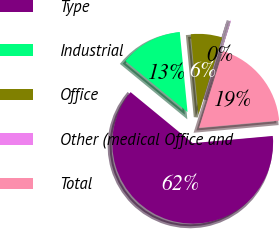Convert chart to OTSL. <chart><loc_0><loc_0><loc_500><loc_500><pie_chart><fcel>Type<fcel>Industrial<fcel>Office<fcel>Other (medical Office and<fcel>Total<nl><fcel>62.38%<fcel>12.52%<fcel>6.29%<fcel>0.06%<fcel>18.75%<nl></chart> 